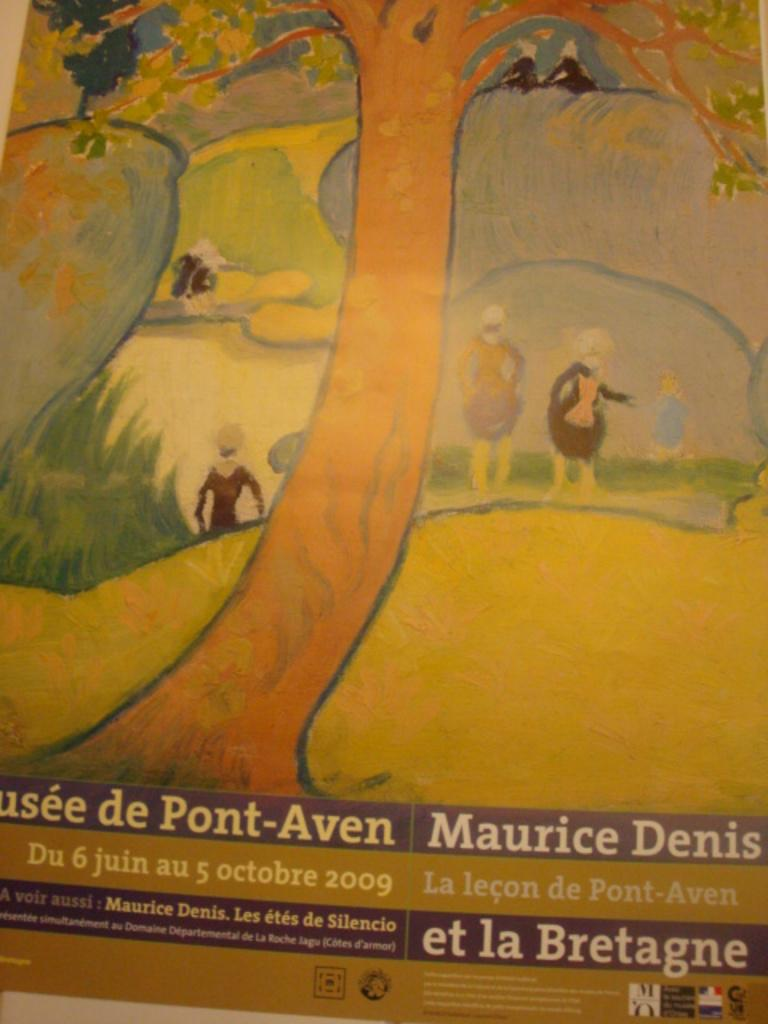What is the main subject of the image? The main subject of the image is a painting. Can you describe the painting in more detail? Yes, there is text on the painting. What type of button is attached to the base of the painting in the image? There is no button or base present in the image; it only features a painting with text. 